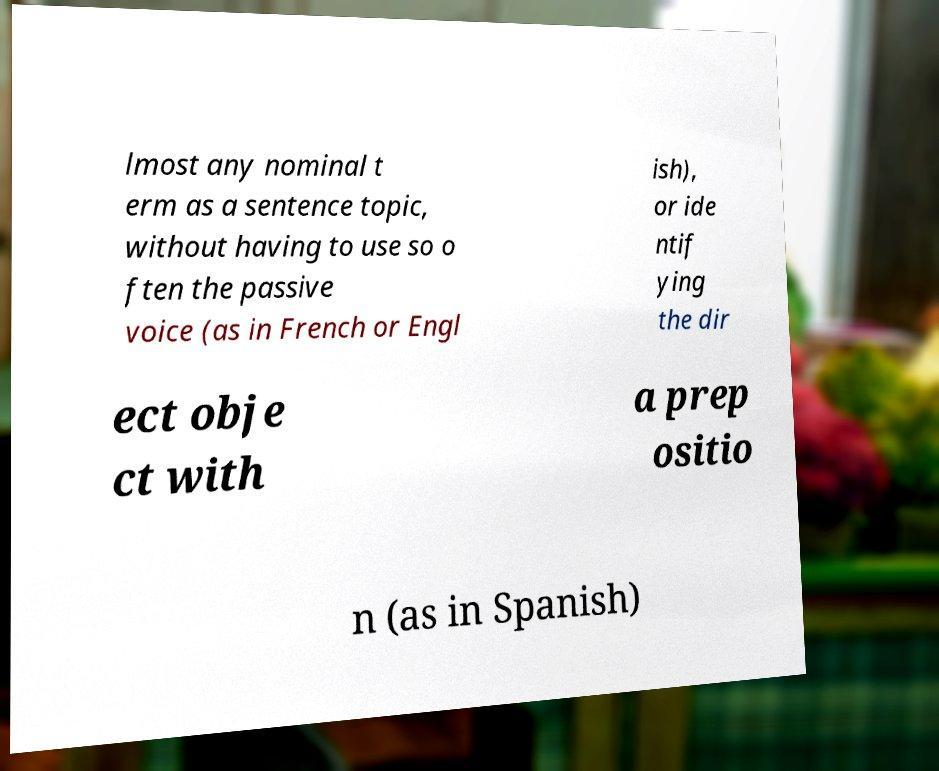Please identify and transcribe the text found in this image. lmost any nominal t erm as a sentence topic, without having to use so o ften the passive voice (as in French or Engl ish), or ide ntif ying the dir ect obje ct with a prep ositio n (as in Spanish) 